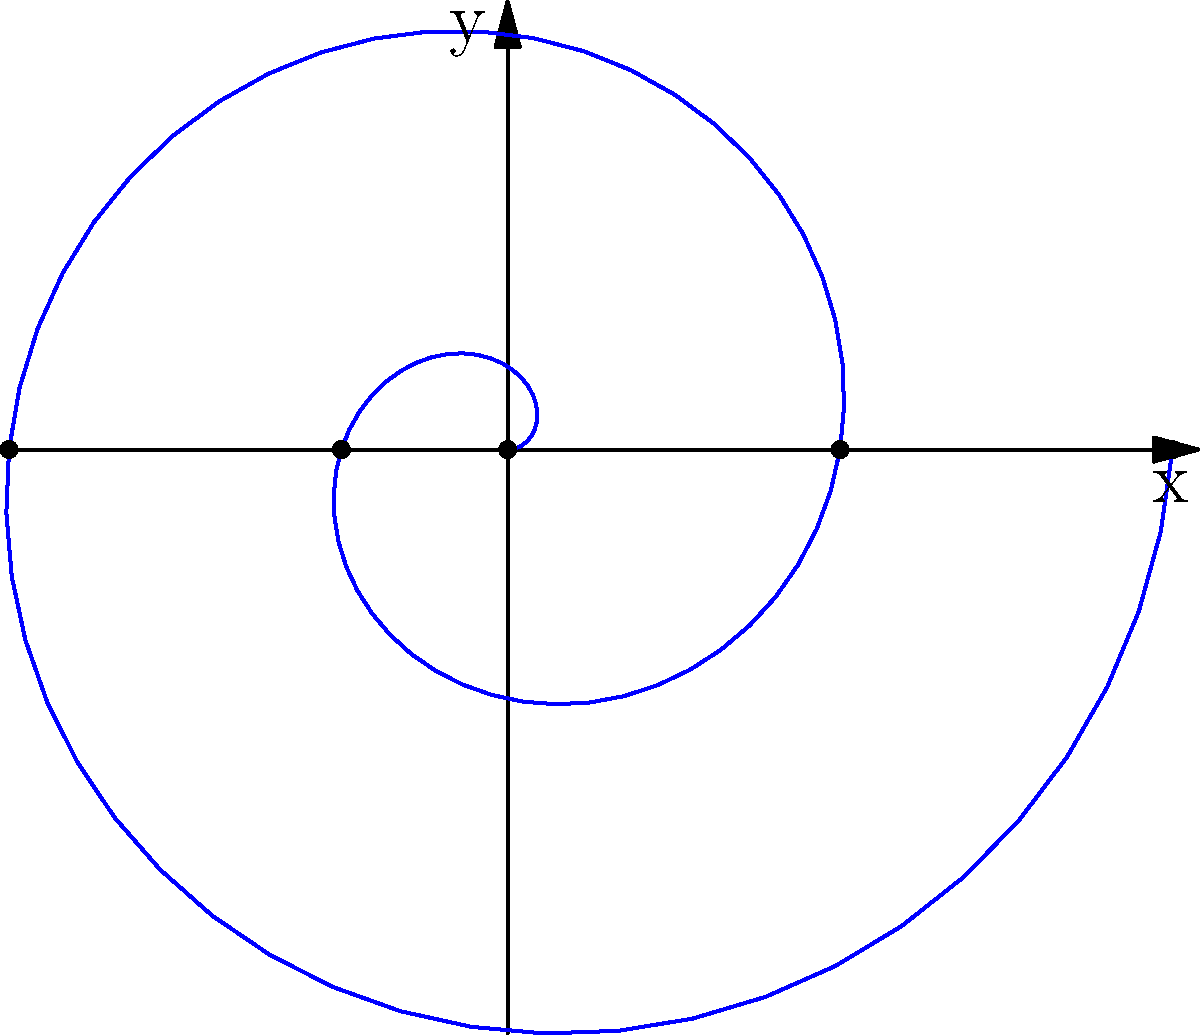In a circular theater, the seats are arranged in a spiral pattern represented by the polar equation $r = 0.2\theta$, where $r$ is the distance from the center and $\theta$ is the angle in radians. If the theater has 4 full rotations of seating, what is the straight-line distance between the first and last seat in the spiral? To solve this problem, let's follow these steps:

1) The spiral makes 4 full rotations, so the last seat is at $\theta = 4\pi$ radians.

2) For the first seat (at the start of the spiral):
   $r_1 = 0.2 \cdot 0 = 0$
   $(\theta_1, r_1) = (0, 0)$

3) For the last seat:
   $r_2 = 0.2 \cdot 4\pi = 0.8\pi$
   $(\theta_2, r_2) = (4\pi, 0.8\pi)$

4) To convert from polar to Cartesian coordinates:
   $x = r \cos(\theta)$
   $y = r \sin(\theta)$

   Last seat: $(x_2, y_2) = (0.8\pi \cos(4\pi), 0.8\pi \sin(4\pi)) = (0.8\pi, 0)$

5) The straight-line distance is the distance between $(0,0)$ and $(0.8\pi, 0)$

6) Using the distance formula:
   $d = \sqrt{(x_2-x_1)^2 + (y_2-y_1)^2} = \sqrt{(0.8\pi-0)^2 + (0-0)^2} = 0.8\pi$

Therefore, the straight-line distance between the first and last seat is $0.8\pi$ units.
Answer: $0.8\pi$ units 